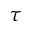<formula> <loc_0><loc_0><loc_500><loc_500>\tau</formula> 